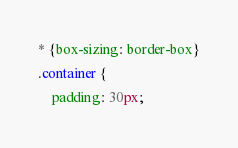<code> <loc_0><loc_0><loc_500><loc_500><_CSS_>* {box-sizing: border-box}
.container {
    padding: 30px;</code> 